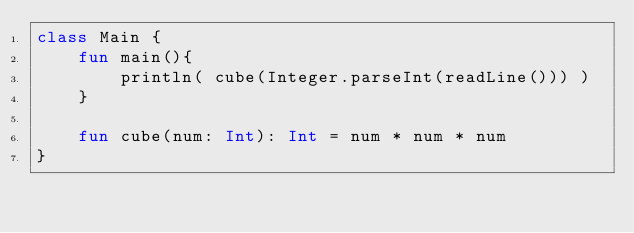<code> <loc_0><loc_0><loc_500><loc_500><_Kotlin_>class Main {
    fun main(){        
        println( cube(Integer.parseInt(readLine())) )
    }

    fun cube(num: Int): Int = num * num * num
}</code> 